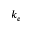Convert formula to latex. <formula><loc_0><loc_0><loc_500><loc_500>k _ { e }</formula> 